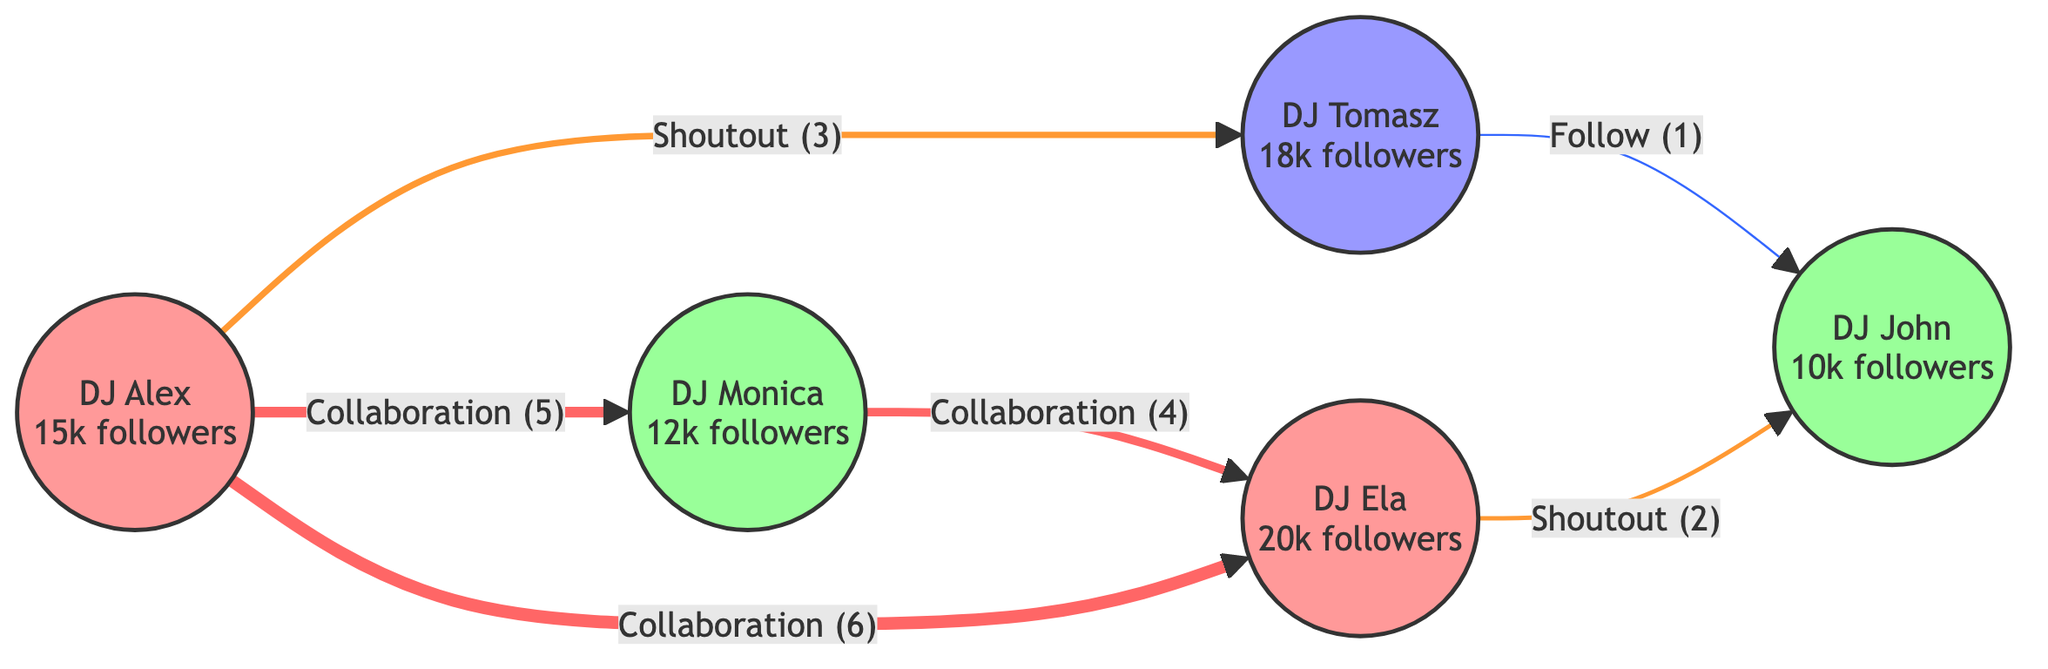How many DJs are in the diagram? The diagram has a total of 5 nodes representing DJs. You can count the nodes: DJ Alex, DJ Monica, DJ Tomasz, DJ Ela, and DJ John.
Answer: 5 What genre is DJ Tomasz associated with? Each DJ has a specific genre mentioned alongside their name in the diagram. DJ Tomasz's genre is listed as Trance.
Answer: Trance Who has the highest number of followers? To find this, compare the follower counts of all the DJs listed. DJ Ela has 20,000 followers, which is higher than the others (DJ Alex has 15,000, DJ Monica has 12,000, DJ Tomasz has 18,000, and DJ John has 10,000).
Answer: DJ Ela What type of interaction exists between DJ Alex and DJ Elaine? The edge connecting DJ Alex and DJ Ela indicates a collaboration relationship, as described in the diagram. The weight of the interaction is noted as 6.
Answer: collaboration Which DJ collaborates with the most other DJs? To determine this, observe the relationships each DJ has. DJ Alex collaborates with DJ Monica and DJ Ela, totaling 2 collaborations. DJ Monica collaborates with DJ Ela (1), DJ Tomasz collaborates with DJ John (1), and DJ Ela collaborates with DJ Alex (1). DJ Alex stands out as having multiple collaborations.
Answer: DJ Alex What is the weight of the interaction between DJ Tomasz and DJ John? The interaction between DJ Tomasz and DJ John is classified as a follow, and the weight of this particular interaction is specified as 1.
Answer: 1 How does the interaction type differ between DJ Alex and DJ Tomasz, and DJ Monica and DJ Ela? The edge connecting DJ Alex and DJ Tomasz indicates a shoutout interaction with a weight of 3, whereas the edge connecting DJ Monica and DJ Ela indicates a collaboration interaction with a weight of 4. The type of interaction differs (shoutout vs. collaboration), and the weights differ as well.
Answer: different types Which DJ is in the techno genre and how many followers do they have? Looking through the nodes, DJ Monica is categorized under the techno genre and has 12,000 followers.
Answer: DJ Monica, 12,000 followers 